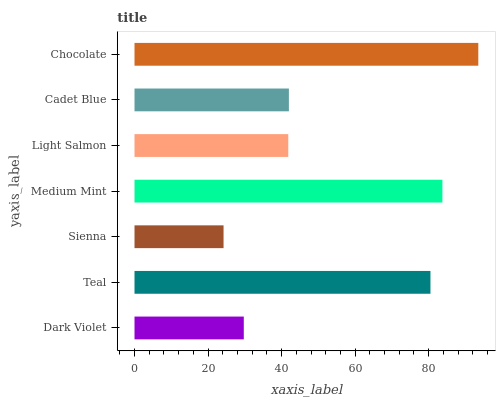Is Sienna the minimum?
Answer yes or no. Yes. Is Chocolate the maximum?
Answer yes or no. Yes. Is Teal the minimum?
Answer yes or no. No. Is Teal the maximum?
Answer yes or no. No. Is Teal greater than Dark Violet?
Answer yes or no. Yes. Is Dark Violet less than Teal?
Answer yes or no. Yes. Is Dark Violet greater than Teal?
Answer yes or no. No. Is Teal less than Dark Violet?
Answer yes or no. No. Is Cadet Blue the high median?
Answer yes or no. Yes. Is Cadet Blue the low median?
Answer yes or no. Yes. Is Dark Violet the high median?
Answer yes or no. No. Is Sienna the low median?
Answer yes or no. No. 